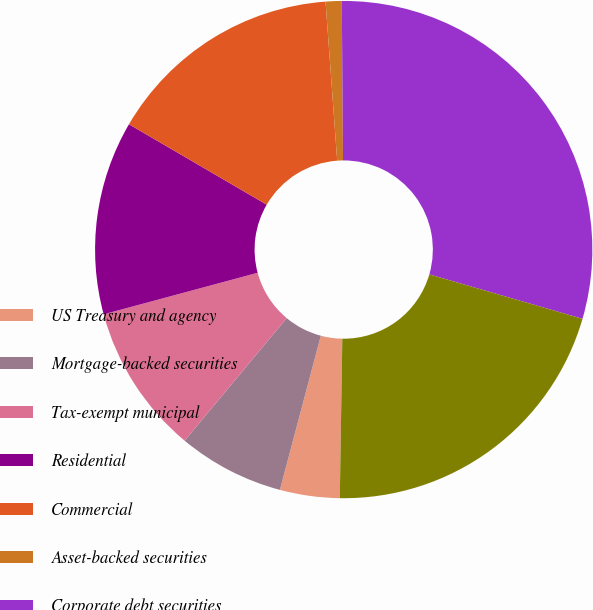Convert chart to OTSL. <chart><loc_0><loc_0><loc_500><loc_500><pie_chart><fcel>US Treasury and agency<fcel>Mortgage-backed securities<fcel>Tax-exempt municipal<fcel>Residential<fcel>Commercial<fcel>Asset-backed securities<fcel>Corporate debt securities<fcel>Total debt securities<nl><fcel>3.88%<fcel>6.92%<fcel>9.76%<fcel>12.6%<fcel>15.43%<fcel>1.04%<fcel>29.62%<fcel>20.76%<nl></chart> 